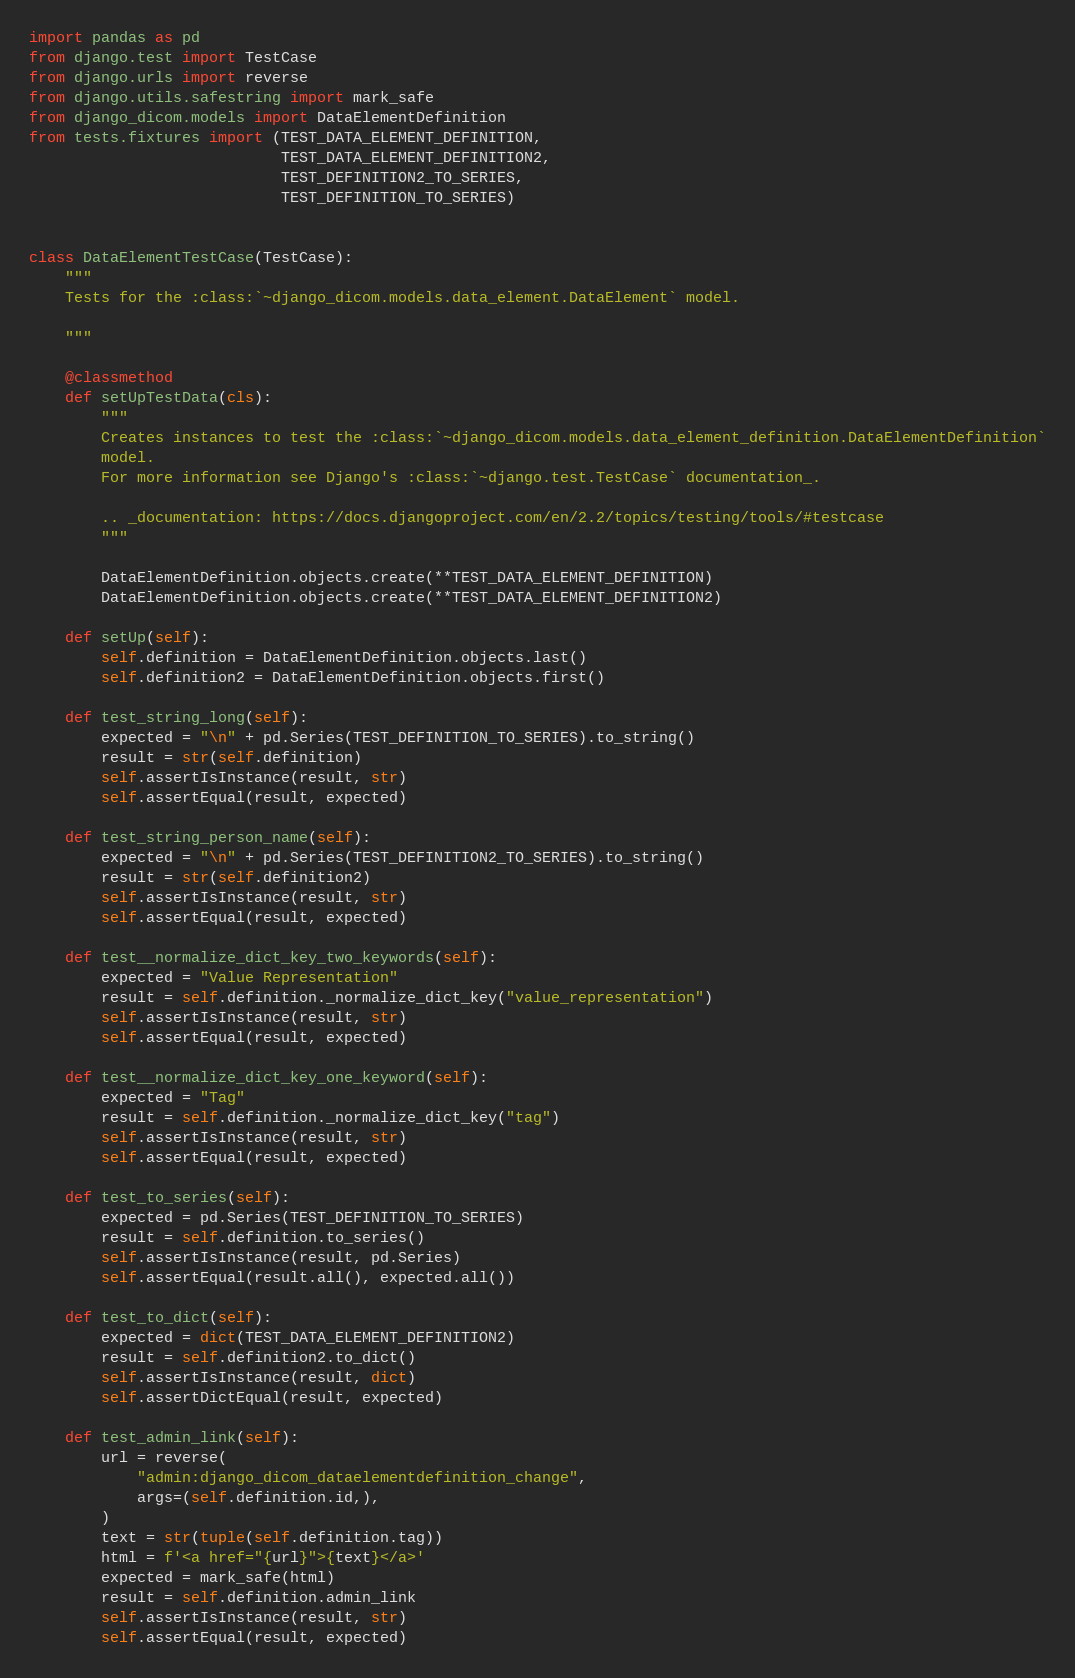Convert code to text. <code><loc_0><loc_0><loc_500><loc_500><_Python_>import pandas as pd
from django.test import TestCase
from django.urls import reverse
from django.utils.safestring import mark_safe
from django_dicom.models import DataElementDefinition
from tests.fixtures import (TEST_DATA_ELEMENT_DEFINITION,
                            TEST_DATA_ELEMENT_DEFINITION2,
                            TEST_DEFINITION2_TO_SERIES,
                            TEST_DEFINITION_TO_SERIES)


class DataElementTestCase(TestCase):
    """
    Tests for the :class:`~django_dicom.models.data_element.DataElement` model.

    """

    @classmethod
    def setUpTestData(cls):
        """
        Creates instances to test the :class:`~django_dicom.models.data_element_definition.DataElementDefinition`
        model.
        For more information see Django's :class:`~django.test.TestCase` documentation_.

        .. _documentation: https://docs.djangoproject.com/en/2.2/topics/testing/tools/#testcase
        """

        DataElementDefinition.objects.create(**TEST_DATA_ELEMENT_DEFINITION)
        DataElementDefinition.objects.create(**TEST_DATA_ELEMENT_DEFINITION2)

    def setUp(self):
        self.definition = DataElementDefinition.objects.last()
        self.definition2 = DataElementDefinition.objects.first()

    def test_string_long(self):
        expected = "\n" + pd.Series(TEST_DEFINITION_TO_SERIES).to_string()
        result = str(self.definition)
        self.assertIsInstance(result, str)
        self.assertEqual(result, expected)

    def test_string_person_name(self):
        expected = "\n" + pd.Series(TEST_DEFINITION2_TO_SERIES).to_string()
        result = str(self.definition2)
        self.assertIsInstance(result, str)
        self.assertEqual(result, expected)

    def test__normalize_dict_key_two_keywords(self):
        expected = "Value Representation"
        result = self.definition._normalize_dict_key("value_representation")
        self.assertIsInstance(result, str)
        self.assertEqual(result, expected)

    def test__normalize_dict_key_one_keyword(self):
        expected = "Tag"
        result = self.definition._normalize_dict_key("tag")
        self.assertIsInstance(result, str)
        self.assertEqual(result, expected)

    def test_to_series(self):
        expected = pd.Series(TEST_DEFINITION_TO_SERIES)
        result = self.definition.to_series()
        self.assertIsInstance(result, pd.Series)
        self.assertEqual(result.all(), expected.all())

    def test_to_dict(self):
        expected = dict(TEST_DATA_ELEMENT_DEFINITION2)
        result = self.definition2.to_dict()
        self.assertIsInstance(result, dict)
        self.assertDictEqual(result, expected)

    def test_admin_link(self):
        url = reverse(
            "admin:django_dicom_dataelementdefinition_change",
            args=(self.definition.id,),
        )
        text = str(tuple(self.definition.tag))
        html = f'<a href="{url}">{text}</a>'
        expected = mark_safe(html)
        result = self.definition.admin_link
        self.assertIsInstance(result, str)
        self.assertEqual(result, expected)
</code> 